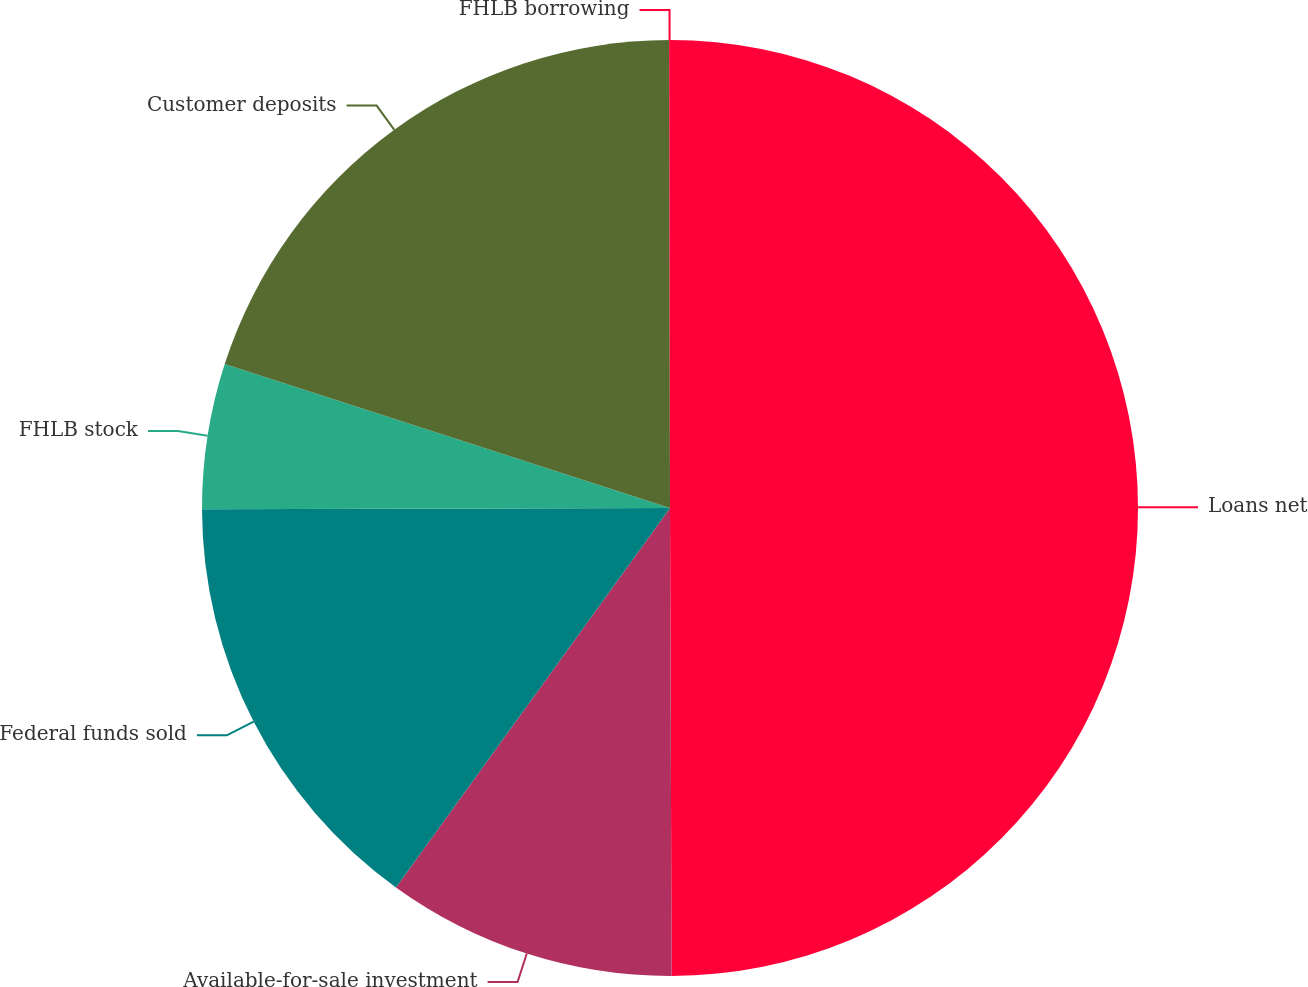Convert chart. <chart><loc_0><loc_0><loc_500><loc_500><pie_chart><fcel>Loans net<fcel>Available-for-sale investment<fcel>Federal funds sold<fcel>FHLB stock<fcel>Customer deposits<fcel>FHLB borrowing<nl><fcel>49.94%<fcel>10.01%<fcel>15.0%<fcel>5.02%<fcel>19.99%<fcel>0.03%<nl></chart> 